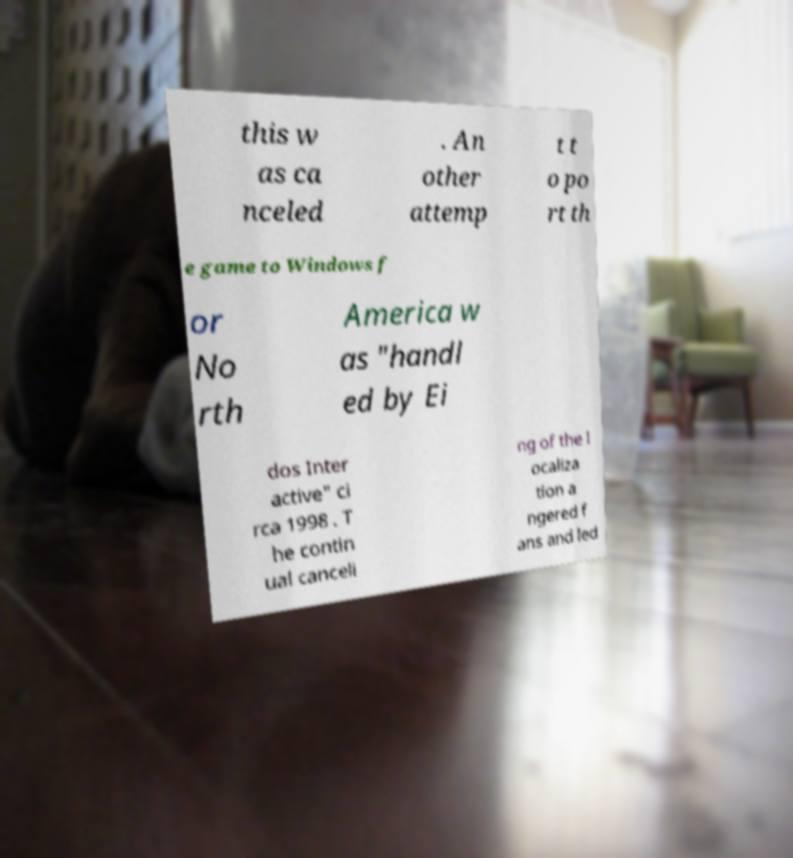For documentation purposes, I need the text within this image transcribed. Could you provide that? this w as ca nceled . An other attemp t t o po rt th e game to Windows f or No rth America w as "handl ed by Ei dos Inter active" ci rca 1998 . T he contin ual canceli ng of the l ocaliza tion a ngered f ans and led 